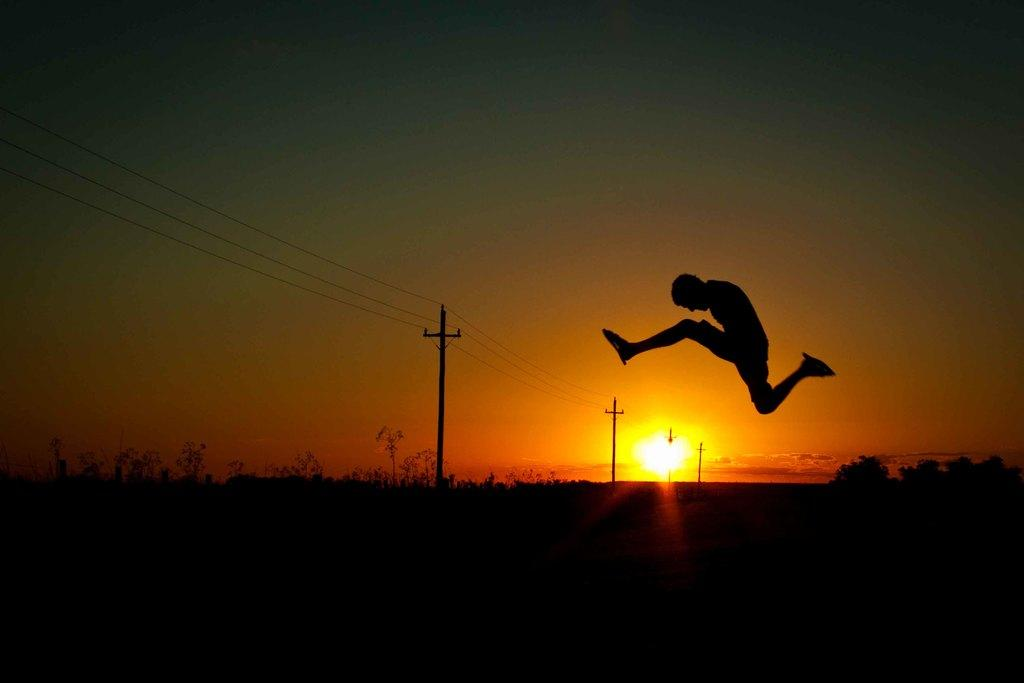What is the person in the image doing? There is a person in the air in the image. What can be seen in the background of the image? There are trees, poles, wires, and the sky visible in the background of the image. What type of education can be seen in the image? There is no reference to education in the image; it features a person in the air and various background elements. 